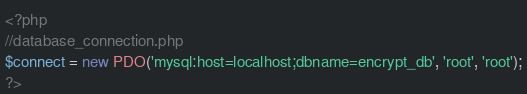Convert code to text. <code><loc_0><loc_0><loc_500><loc_500><_PHP_><?php
//database_connection.php
$connect = new PDO('mysql:host=localhost;dbname=encrypt_db', 'root', 'root');
?>
</code> 